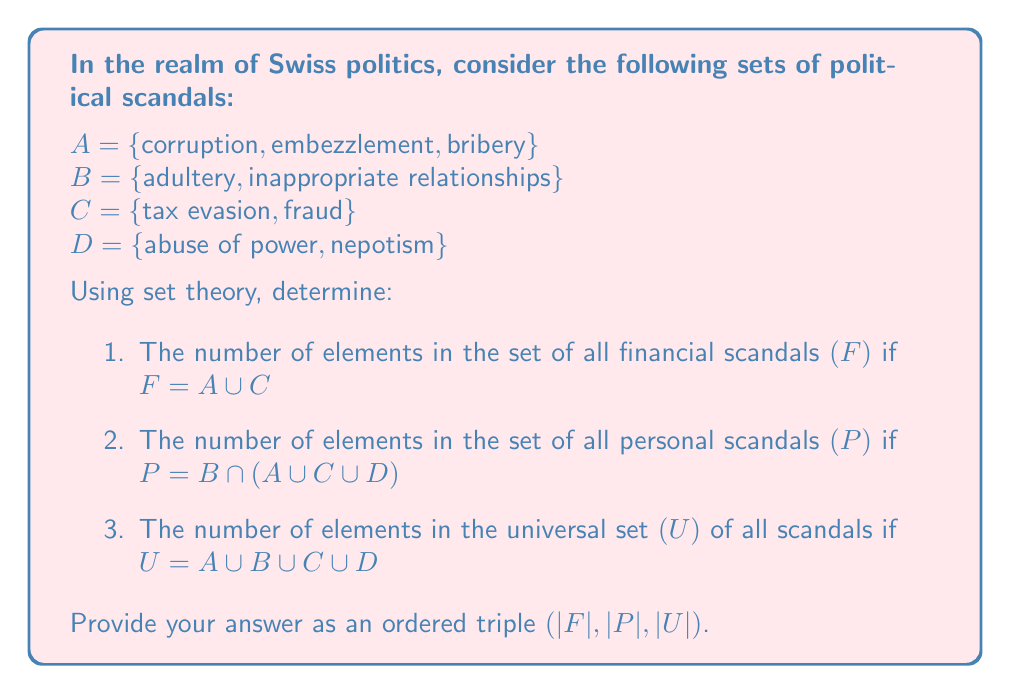Can you answer this question? Let's approach this step-by-step:

1. To find |F| (the number of elements in F):
   F = A ∪ C
   A = {corruption, embezzlement, bribery}
   C = {tax evasion, fraud}
   F = {corruption, embezzlement, bribery, tax evasion, fraud}
   |F| = 5

2. To find |P| (the number of elements in P):
   P = B ∩ (A ∪ C ∪ D)
   B = {adultery, inappropriate relationships}
   A ∪ C ∪ D = {corruption, embezzlement, bribery, tax evasion, fraud, abuse of power, nepotism}
   The intersection of these sets is empty, as there are no common elements.
   P = ∅
   |P| = 0

3. To find |U| (the number of elements in U):
   U = A ∪ B ∪ C ∪ D
   We need to count all unique elements:
   {corruption, embezzlement, bribery, adultery, inappropriate relationships, tax evasion, fraud, abuse of power, nepotism}
   |U| = 9

Therefore, the ordered triple (|F|, |P|, |U|) is (5, 0, 9).
Answer: (5, 0, 9) 